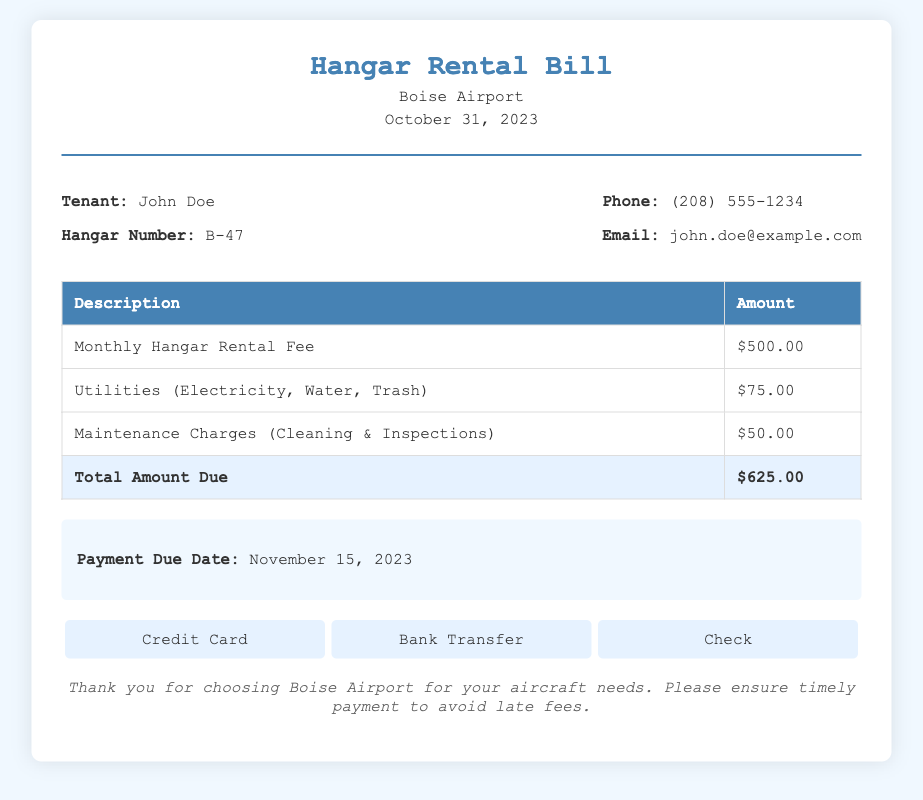What is the tenant's name? The tenant's name is provided at the beginning of the bill information section.
Answer: John Doe What is the hangar number? The hangar number is listed alongside the tenant's name in the bill information section.
Answer: B-47 What is the amount for utilities? The bill specifies the amount charged for utilities under a separate line item in the table.
Answer: $75.00 What is the total amount due? The total amount due is clearly indicated in the last row of the bill table.
Answer: $625.00 What is the payment due date? The document specifies the payment due date in the summary section.
Answer: November 15, 2023 How much is the monthly hangar rental fee? The monthly hangar rental fee is provided in the second row of the bill table.
Answer: $500.00 What maintenance charges are included? Maintenance charges are provided as a description in the bill table, specifying what they cover.
Answer: Cleaning & Inspections What are the payment methods available? The document lists the payment methods in a dedicated section near the end of the bill.
Answer: Credit Card, Bank Transfer, Check How much is the maintenance charge? The specific maintenance charge amount is mentioned in the bill table.
Answer: $50.00 